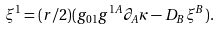Convert formula to latex. <formula><loc_0><loc_0><loc_500><loc_500>\xi ^ { 1 } = ( r / 2 ) ( g _ { 0 1 } g ^ { 1 A } \partial _ { A } \kappa - D _ { B } \xi ^ { B } ) .</formula> 